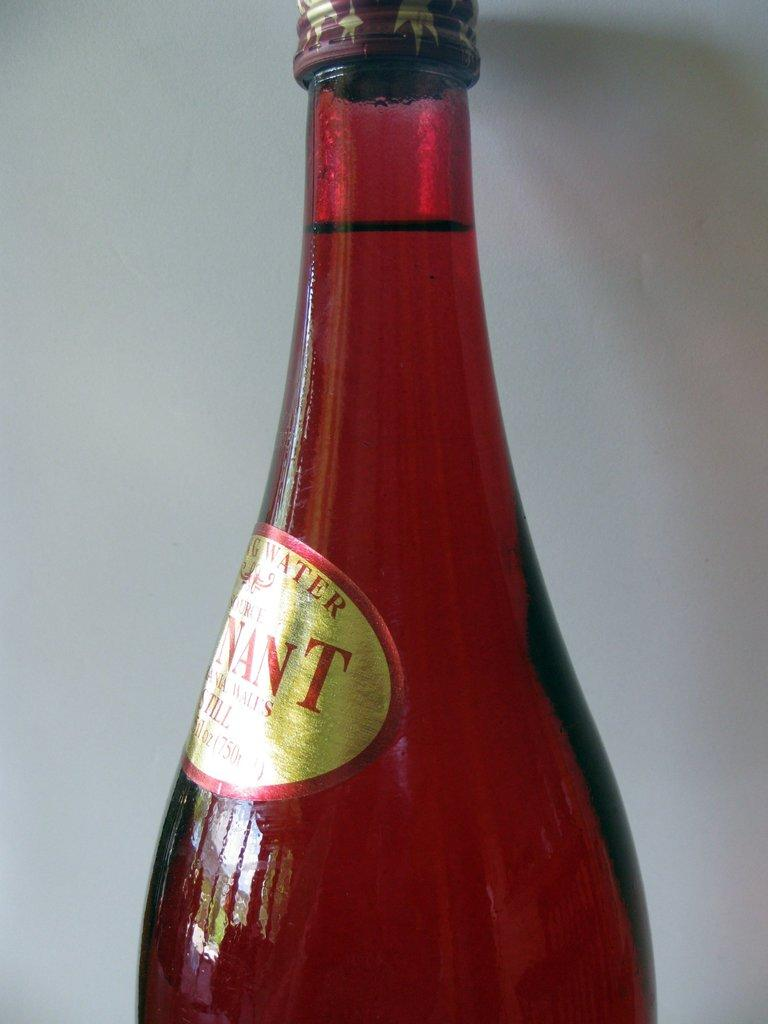Provide a one-sentence caption for the provided image. A bottle has the partial word Nant on its sticker. 